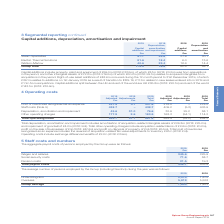According to Spirax Sarco Engineering Plc's financial document, What information does the table provide? The aggregate payroll costs of persons employed by the Group. The document states: "5 Staff costs and numbers The aggregate payroll costs of persons employed by the Group were as follows:..." Also, What was the total payroll costs in 2018? According to the financial document, 403.9 (in millions). The relevant text states: "Pension costs 21.5 19.3 Total payroll costs 438.7 403.9..." Also, What are the different components that make up the total payroll costs? The document contains multiple relevant values: Wages and salaries, Social security costs, Pension costs. From the document: "aries 345.6 325.9 Social security costs 71.6 58.7 Pension costs 21.5 19.3 Total payroll costs 438.7 403.9 2018 £m Wages and salaries 345.6 325.9 Socia..." Additionally, In which year was the amount of wages and salaries larger? According to the financial document, 2019. The relevant text states: "2019 2018 United Kingdom 2,014 1,875 Overseas 5,819 5,528 Group average 7,833 7,403..." Also, can you calculate: What was the change in social security costs in 2019 from 2018? Based on the calculation: 71.6-58.7, the result is 12.9 (in millions). This is based on the information: "es and salaries 345.6 325.9 Social security costs 71.6 58.7 Pension costs 21.5 19.3 Total payroll costs 438.7 403.9 d salaries 345.6 325.9 Social security costs 71.6 58.7 Pension costs 21.5 19.3 Total..." The key data points involved are: 58.7, 71.6. Also, can you calculate: What was the percentage change in social security costs in 2019 from 2018? To answer this question, I need to perform calculations using the financial data. The calculation is: (71.6-58.7)/58.7, which equals 21.98 (percentage). This is based on the information: "es and salaries 345.6 325.9 Social security costs 71.6 58.7 Pension costs 21.5 19.3 Total payroll costs 438.7 403.9 d salaries 345.6 325.9 Social security costs 71.6 58.7 Pension costs 21.5 19.3 Total..." The key data points involved are: 58.7, 71.6. 